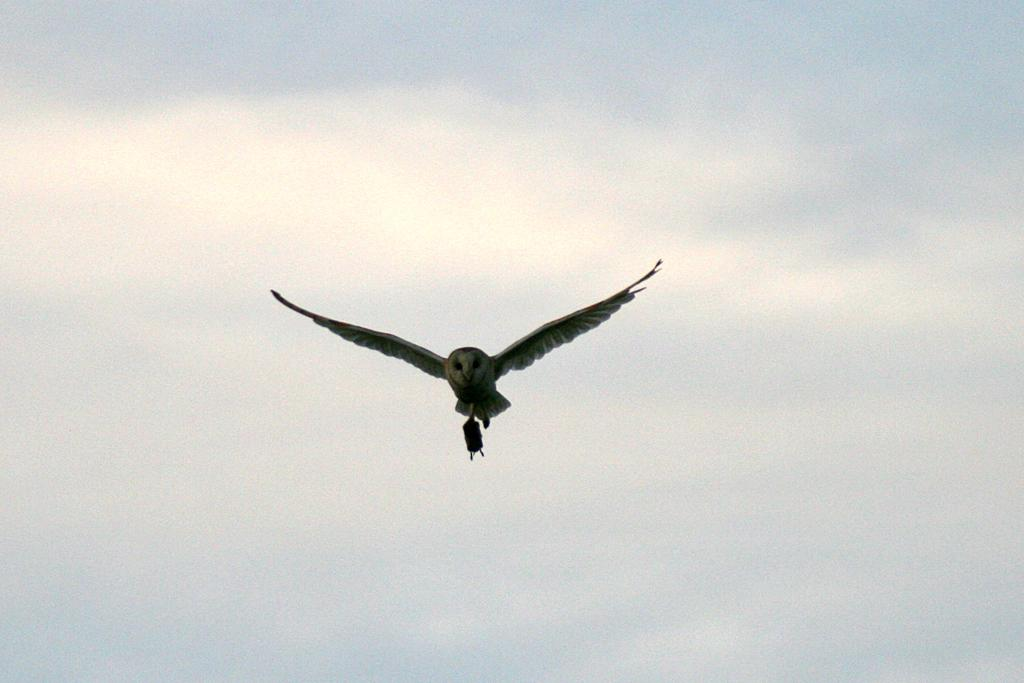What is the main subject of the image? The main subject of the image is a bird flying. Where is the bird located in the image? The bird is in the sky. What can be seen in the background of the image? The sky is visible in the background of the image. What is the texture of the bird's feathers in the image? The texture of the bird's feathers cannot be determined from the image, as it only shows the bird flying in the sky. 